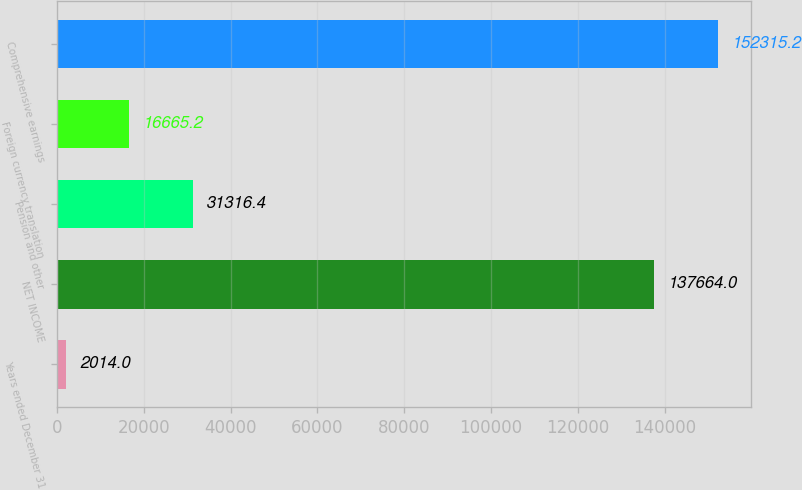<chart> <loc_0><loc_0><loc_500><loc_500><bar_chart><fcel>Years ended December 31<fcel>NET INCOME<fcel>Pension and other<fcel>Foreign currency translation<fcel>Comprehensive earnings<nl><fcel>2014<fcel>137664<fcel>31316.4<fcel>16665.2<fcel>152315<nl></chart> 